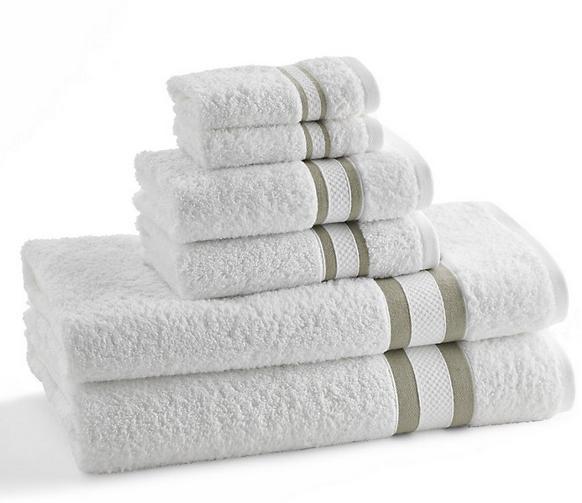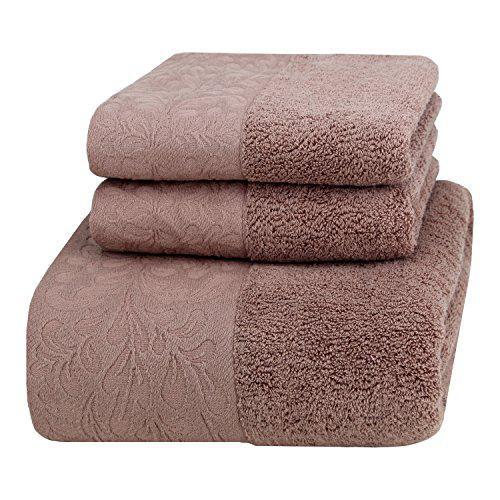The first image is the image on the left, the second image is the image on the right. Given the left and right images, does the statement "In one image, six towels the same color are folded and stacked according to size, smallest on top." hold true? Answer yes or no. Yes. The first image is the image on the left, the second image is the image on the right. Examine the images to the left and right. Is the description "IN at least one image there is a tower of six folded towels." accurate? Answer yes or no. Yes. 